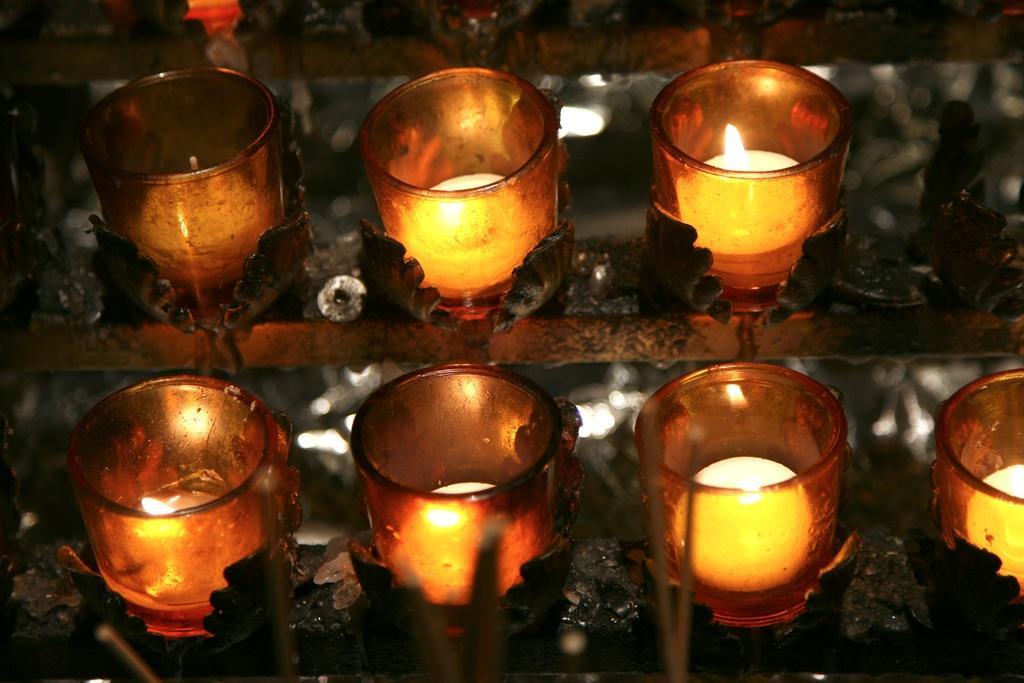Describe this image in one or two sentences. In the foreground of this image, there are glass candles to the candle holders. 